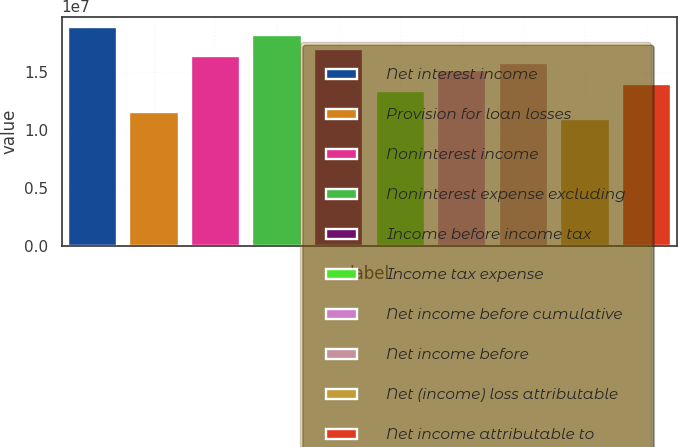<chart> <loc_0><loc_0><loc_500><loc_500><bar_chart><fcel>Net interest income<fcel>Provision for loan losses<fcel>Noninterest income<fcel>Noninterest expense excluding<fcel>Income before income tax<fcel>Income tax expense<fcel>Net income before cumulative<fcel>Net income before<fcel>Net (income) loss attributable<fcel>Net income attributable to<nl><fcel>1.88525e+07<fcel>1.15548e+07<fcel>1.64199e+07<fcel>1.82444e+07<fcel>1.70281e+07<fcel>1.33792e+07<fcel>1.52036e+07<fcel>1.58118e+07<fcel>1.09466e+07<fcel>1.39873e+07<nl></chart> 